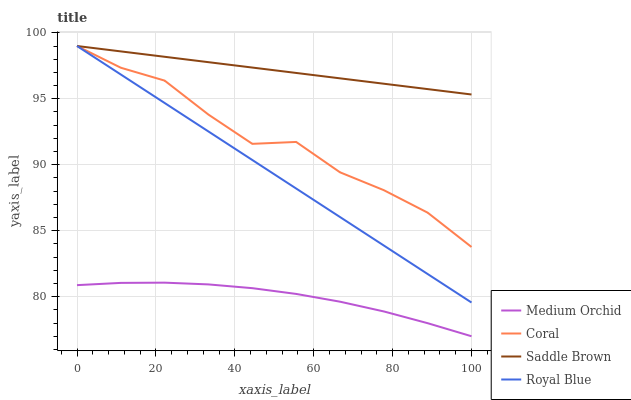Does Medium Orchid have the minimum area under the curve?
Answer yes or no. Yes. Does Saddle Brown have the maximum area under the curve?
Answer yes or no. Yes. Does Coral have the minimum area under the curve?
Answer yes or no. No. Does Coral have the maximum area under the curve?
Answer yes or no. No. Is Saddle Brown the smoothest?
Answer yes or no. Yes. Is Coral the roughest?
Answer yes or no. Yes. Is Medium Orchid the smoothest?
Answer yes or no. No. Is Medium Orchid the roughest?
Answer yes or no. No. Does Coral have the lowest value?
Answer yes or no. No. Does Saddle Brown have the highest value?
Answer yes or no. Yes. Does Medium Orchid have the highest value?
Answer yes or no. No. Is Medium Orchid less than Royal Blue?
Answer yes or no. Yes. Is Coral greater than Medium Orchid?
Answer yes or no. Yes. Does Saddle Brown intersect Coral?
Answer yes or no. Yes. Is Saddle Brown less than Coral?
Answer yes or no. No. Is Saddle Brown greater than Coral?
Answer yes or no. No. Does Medium Orchid intersect Royal Blue?
Answer yes or no. No. 